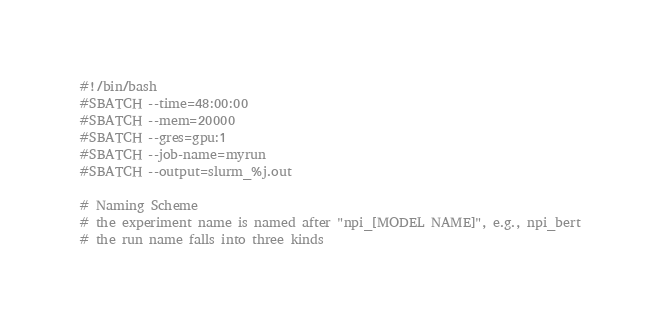<code> <loc_0><loc_0><loc_500><loc_500><_Bash_>#!/bin/bash
#SBATCH --time=48:00:00
#SBATCH --mem=20000
#SBATCH --gres=gpu:1
#SBATCH --job-name=myrun
#SBATCH --output=slurm_%j.out

# Naming Scheme
# the experiment name is named after "npi_[MODEL NAME]", e.g., npi_bert
# the run name falls into three kinds</code> 